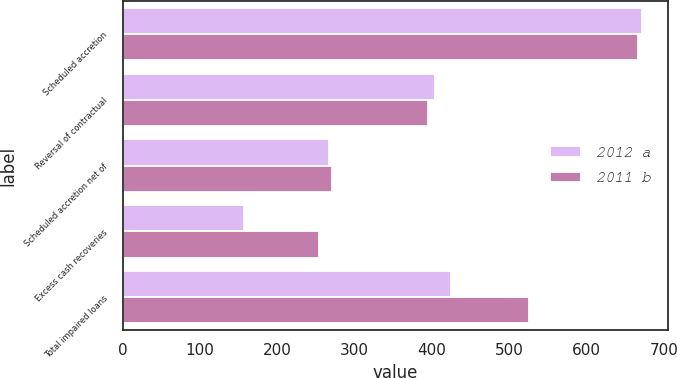Convert chart to OTSL. <chart><loc_0><loc_0><loc_500><loc_500><stacked_bar_chart><ecel><fcel>Scheduled accretion<fcel>Reversal of contractual<fcel>Scheduled accretion net of<fcel>Excess cash recoveries<fcel>Total impaired loans<nl><fcel>2012 a<fcel>671<fcel>404<fcel>267<fcel>157<fcel>424<nl><fcel>2011 b<fcel>666<fcel>395<fcel>271<fcel>254<fcel>525<nl></chart> 